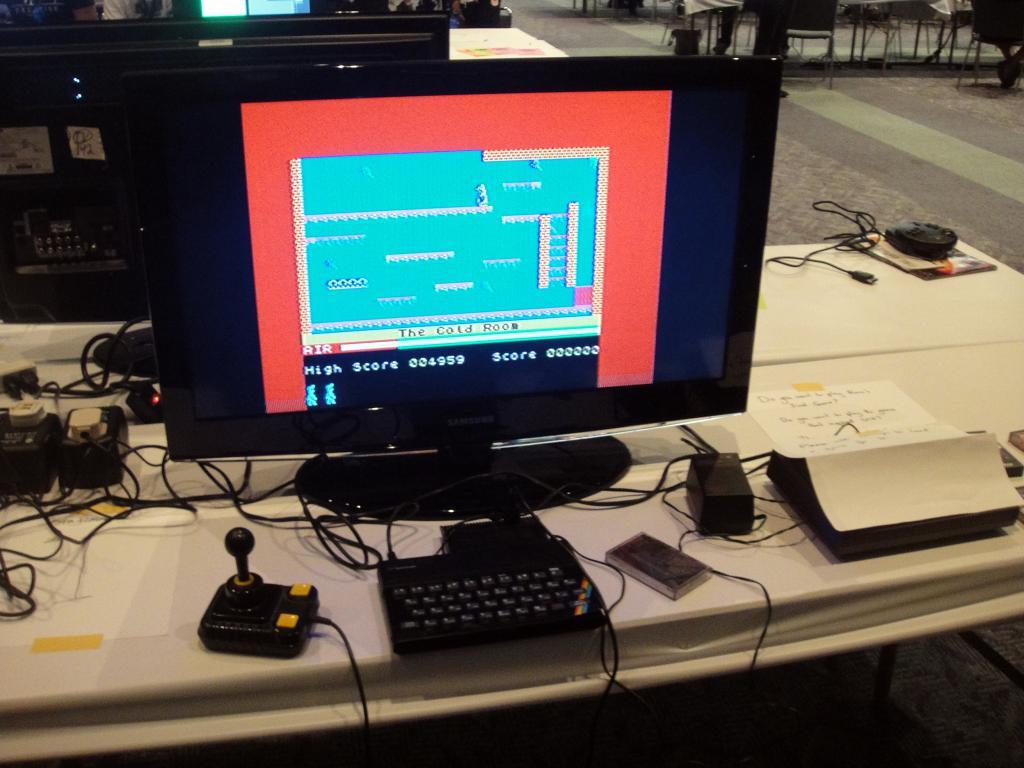What game are they playing?
Your answer should be very brief. The cold room. 